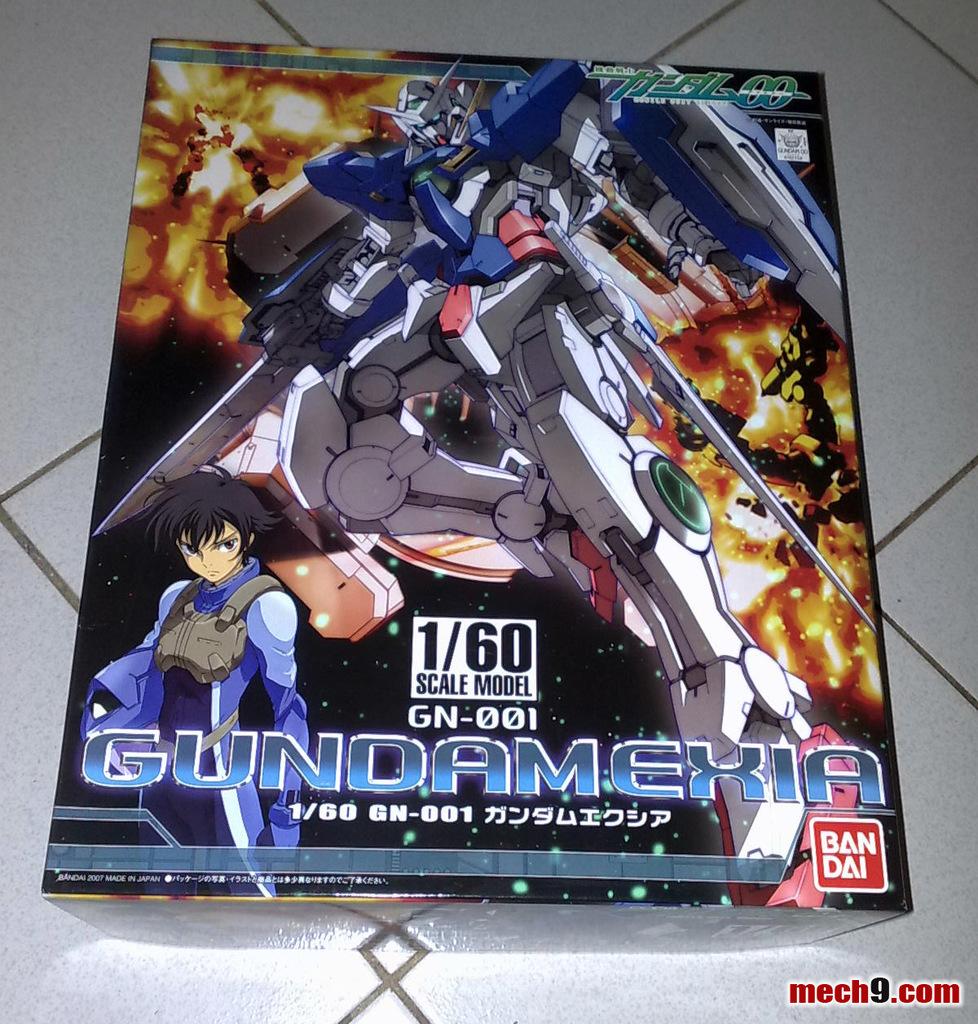What is the name of the comic?
Offer a terse response. Gundamexia. What company produced this comic?
Your response must be concise. Bandai. 